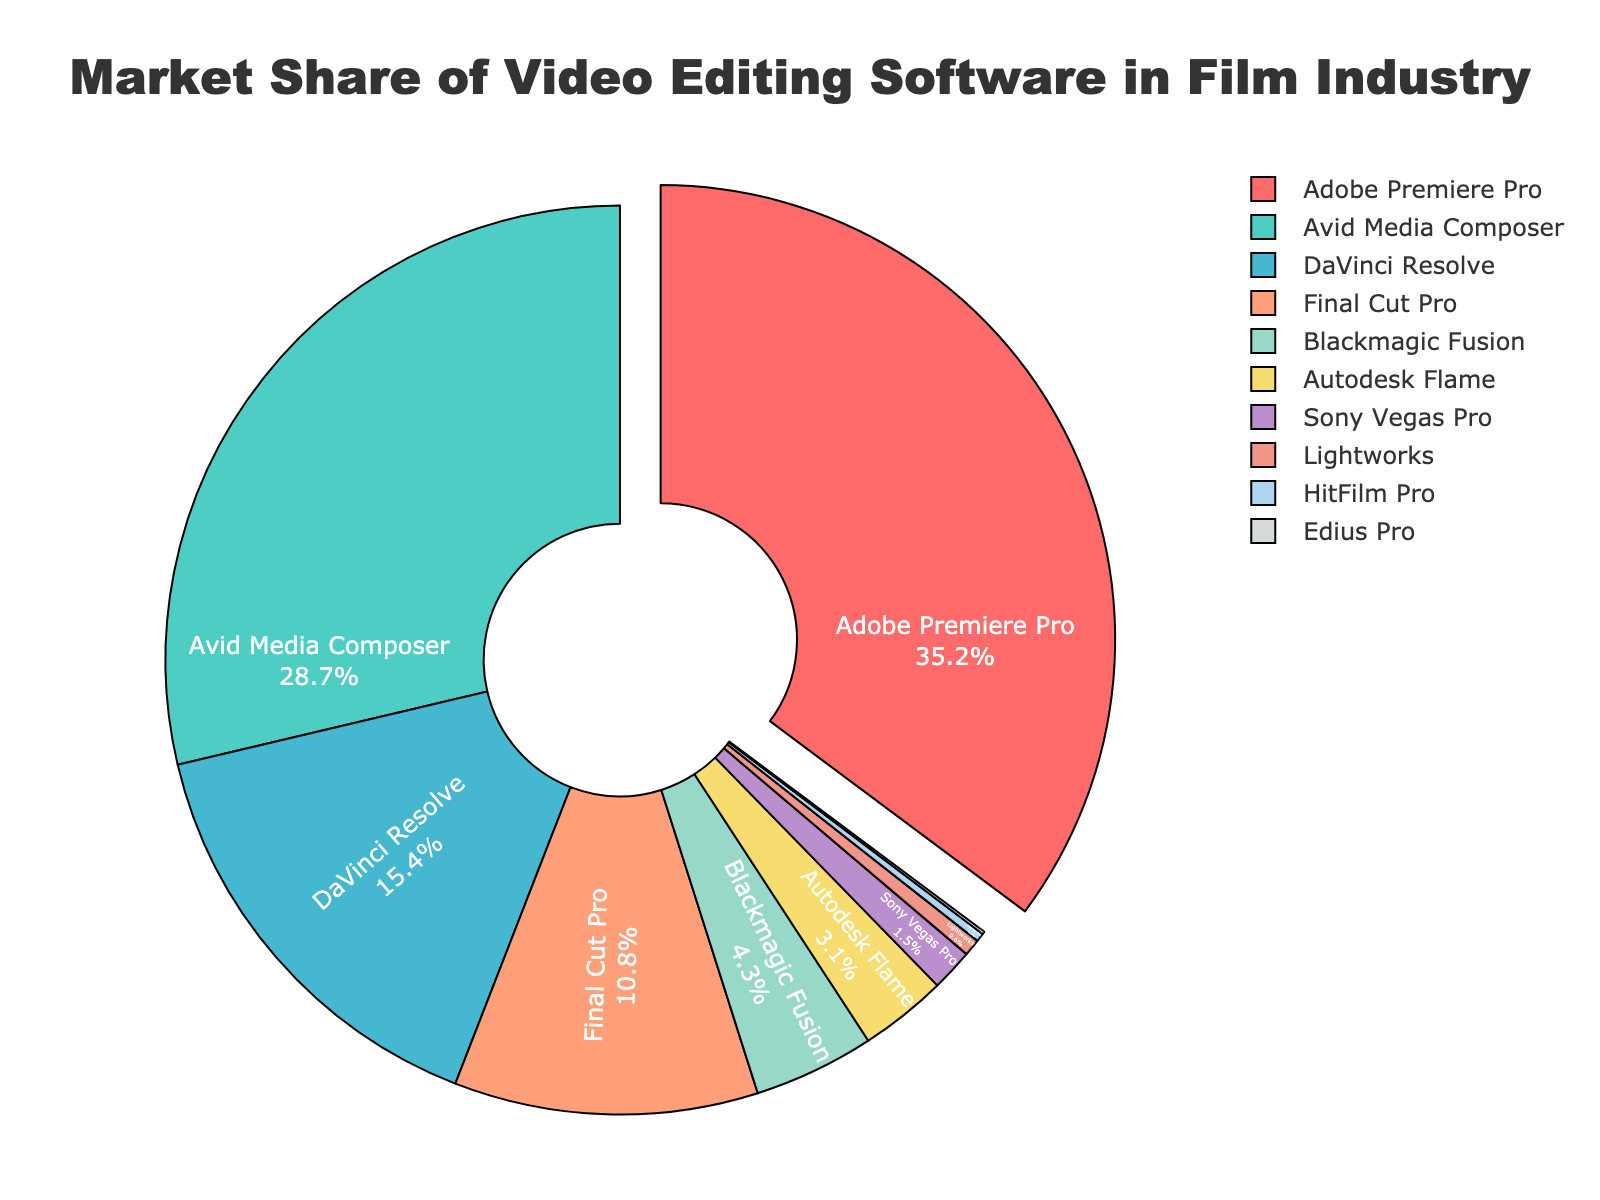Which software has the largest market share? Adobe Premiere Pro has the largest segment, which is visually pulled out from the pie with a label showing 35.2%.
Answer: Adobe Premiere Pro Which two software combined have a market share greater than 50% but less than 60%? Adding Adobe Premiere Pro (35.2%) and Avid Media Composer (28.7%) gives 35.2 + 28.7 = 63.9%, which exceeds 60%. Instead, combining Adobe Premiere Pro (35.2%) and DaVinci Resolve (15.4%) gives 35.2 + 15.4 = 50.6%, which is just above 50%.
Answer: Adobe Premiere Pro and DaVinci Resolve How much larger is the market share of Adobe Premiere Pro compared to Final Cut Pro? The market share of Adobe Premiere Pro is 35.2%, and that of Final Cut Pro is 10.8%. The difference is 35.2 - 10.8 = 24.4%.
Answer: 24.4% What percentage of the market is occupied by software with less than 5% share individually? Adding up the market shares of Blackmagic Fusion (4.3%), Autodesk Flame (3.1%), Sony Vegas Pro (1.5%), Lightworks (0.6%), HitFilm Pro (0.3%), and Edius Pro (0.1%) gives 4.3 + 3.1 + 1.5 + 0.6 + 0.3 + 0.1 = 9.9%.
Answer: 9.9% Which software shares are visually represented in blue and green respectively? The green section, positioned close to the top right, represents Avid Media Composer at 28.7%, and the blue segment, positioned to the left of the green, represents DaVinci Resolve at 15.4%.
Answer: Avid Media Composer and DaVinci Resolve What is the share difference between DaVinci Resolve and Final Cut Pro? DaVinci Resolve has 15.4% and Final Cut Pro has 10.8%. The difference is 15.4 - 10.8 = 4.6%.
Answer: 4.6% What is the combined market share of the three least popular software? The least popular software are Edius Pro (0.1%), HitFilm Pro (0.3%), and Lightworks (0.6%). Adding these gives 0.1 + 0.3 + 0.6 = 1.0%.
Answer: 1.0% Which software occupies the purple segment in the pie chart? The purple section in the pie chart, located near the bottom, represents Blackmagic Fusion with a market share of 4.3%.
Answer: Blackmagic Fusion How does the market share of Autodesk Flame compare to Blackmagic Fusion? Autodesk Flame has a market share of 3.1%, and Blackmagic Fusion has 4.3%. Autodesk Flame has a smaller share than Blackmagic Fusion.
Answer: Smaller than Blackmagic Fusion If DaVinci Resolve increased its market share by 5%, what would its new market share be? DaVinci Resolve's current market share is 15.4%. Adding 5% to it results in 15.4 + 5 = 20.4%.
Answer: 20.4% 